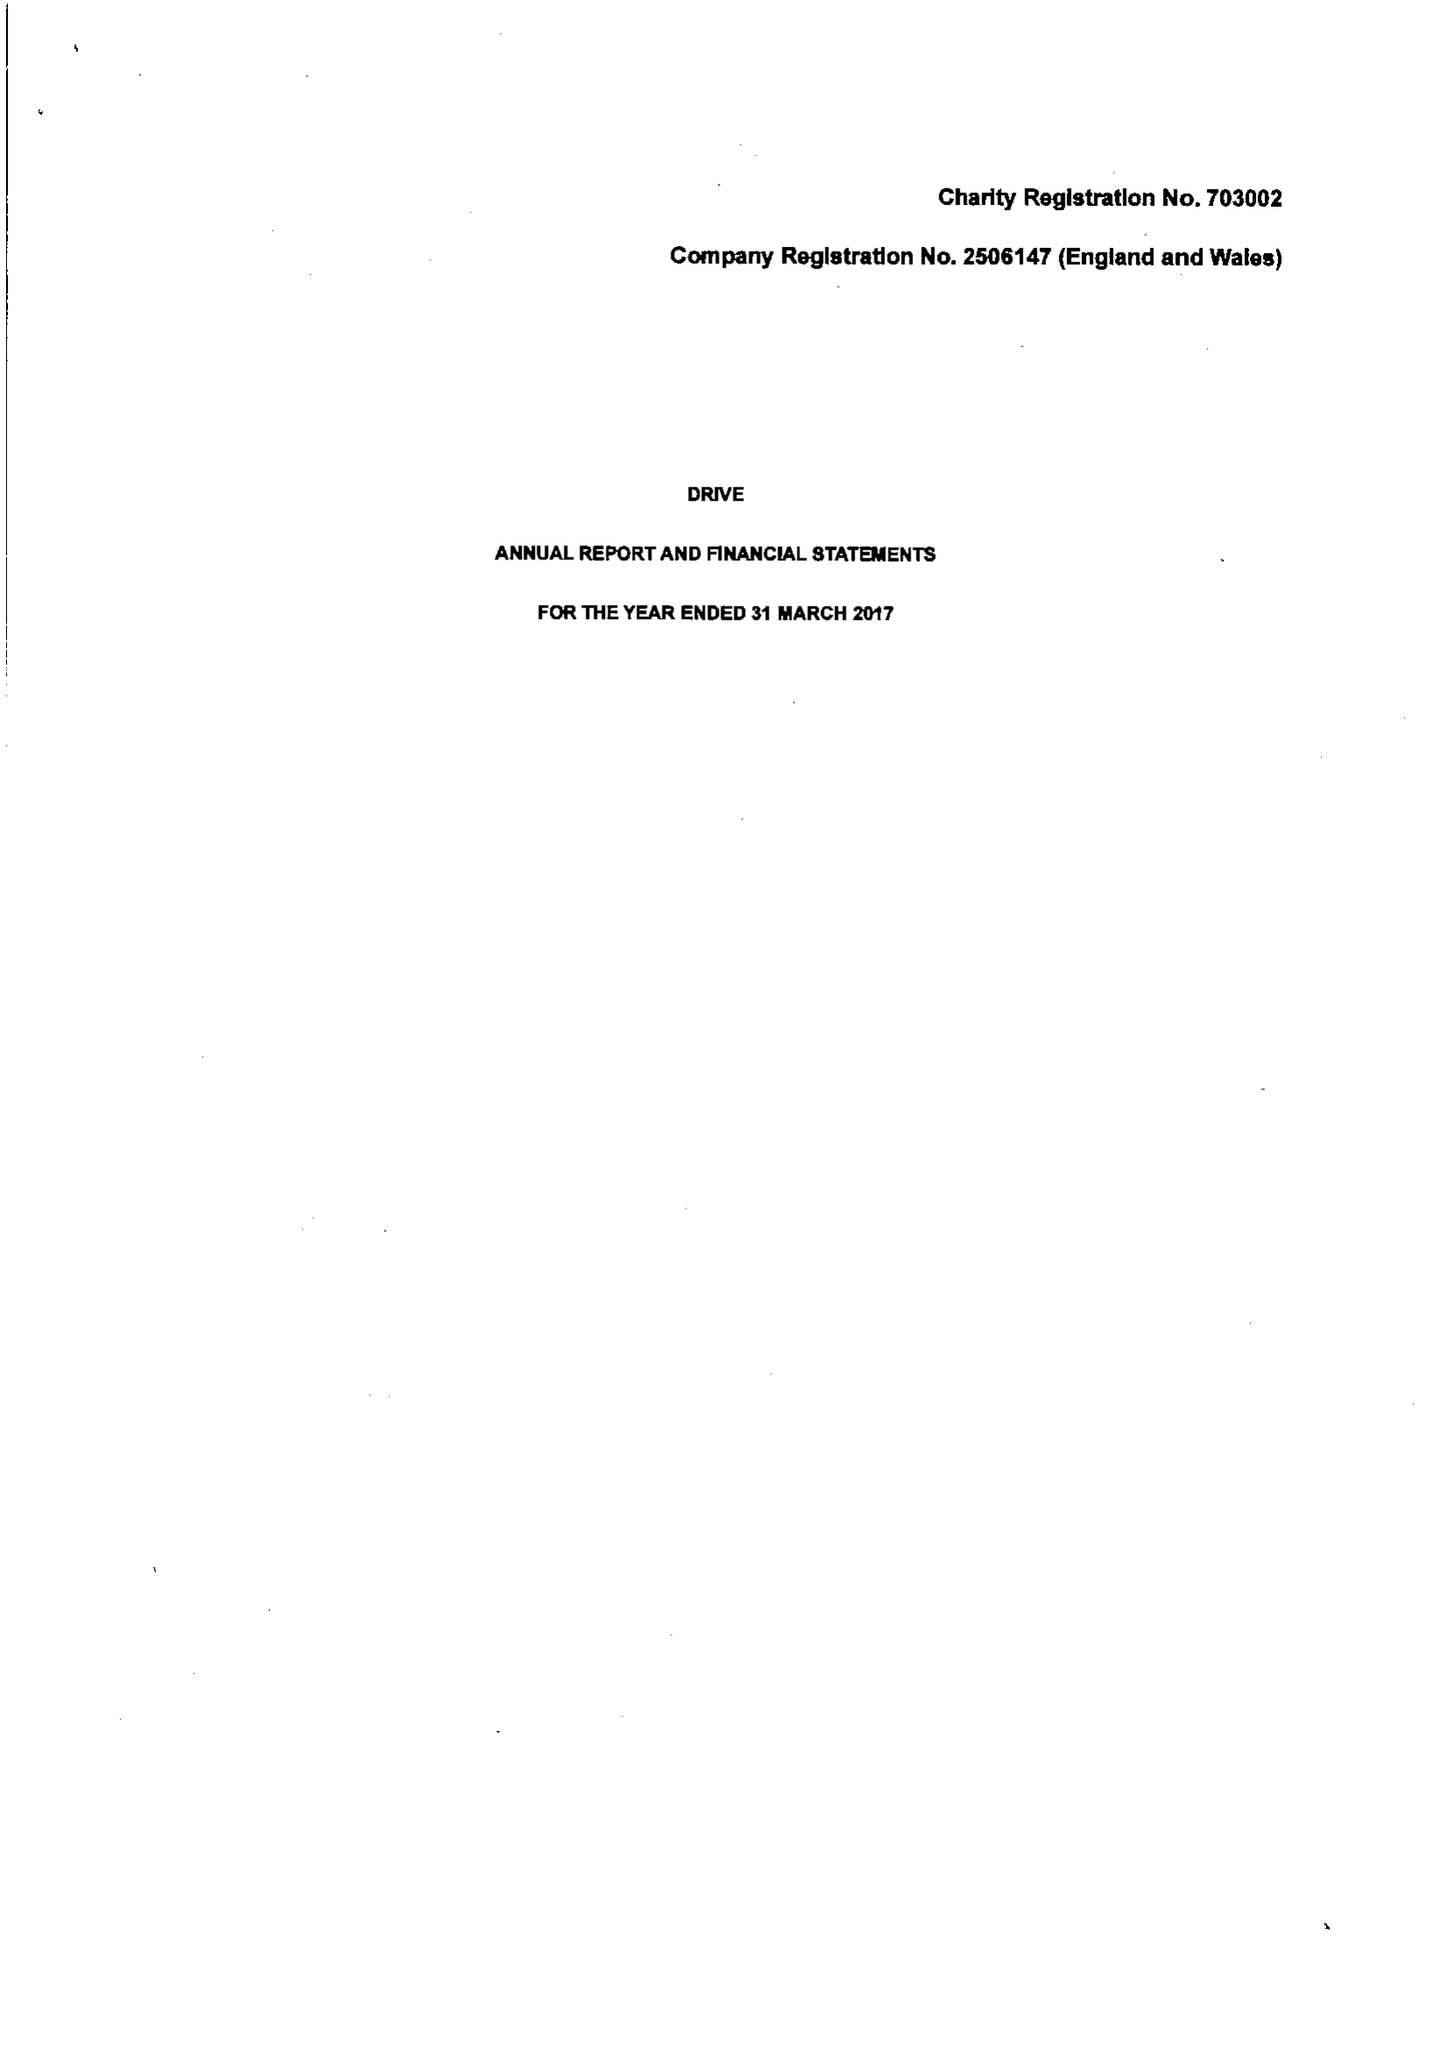What is the value for the charity_number?
Answer the question using a single word or phrase. 703002 